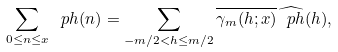<formula> <loc_0><loc_0><loc_500><loc_500>\sum _ { 0 \leq n \leq x } \ p h ( n ) = \sum _ { - m / 2 < h \leq m / 2 } \overline { \gamma _ { m } ( h ; x ) } \widehat { \ p h } ( h ) ,</formula> 